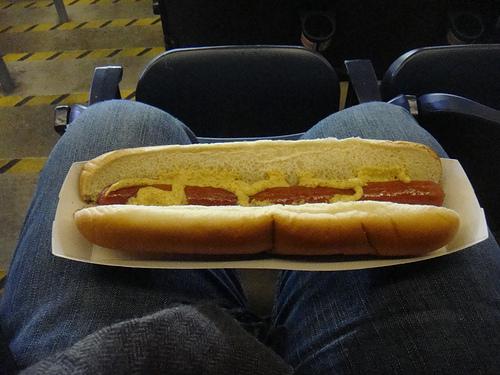What is on the hotdog?
Be succinct. Mustard. Is this hot dog high in sodium?
Write a very short answer. Yes. What is this kind of hot dog called?
Give a very brief answer. Footlong. What is under the food?
Write a very short answer. Tray. Is there kraut on the hot dog?
Short answer required. No. Is the mustard dripping?
Give a very brief answer. No. What is on the paper plate?
Be succinct. Hot dog. Are there any condiments on this hot dog?
Short answer required. Yes. 